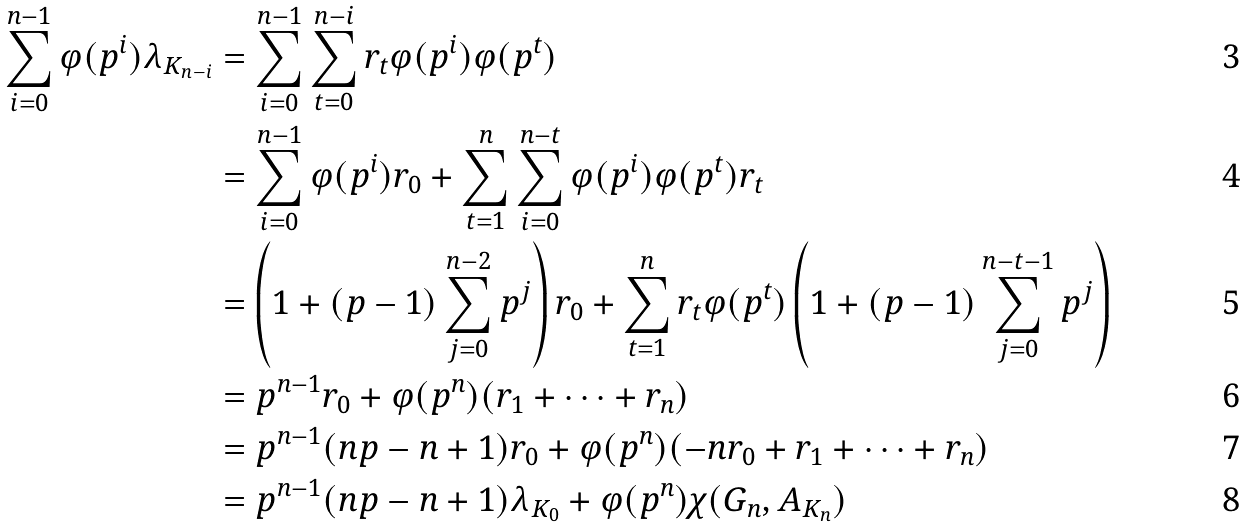Convert formula to latex. <formula><loc_0><loc_0><loc_500><loc_500>\sum _ { i = 0 } ^ { n - 1 } \varphi ( p ^ { i } ) \lambda _ { K _ { n - i } } & = \sum _ { i = 0 } ^ { n - 1 } \sum _ { t = 0 } ^ { n - i } r _ { t } \varphi ( p ^ { i } ) \varphi ( p ^ { t } ) \\ & = \sum _ { i = 0 } ^ { n - 1 } \varphi ( p ^ { i } ) r _ { 0 } + \sum _ { t = 1 } ^ { n } \sum _ { i = 0 } ^ { n - t } \varphi ( p ^ { i } ) \varphi ( p ^ { t } ) r _ { t } \\ & = \left ( 1 + ( p - 1 ) \sum _ { j = 0 } ^ { n - 2 } p ^ { j } \right ) r _ { 0 } + \sum _ { t = 1 } ^ { n } r _ { t } \varphi ( p ^ { t } ) \left ( 1 + ( p - 1 ) \sum _ { j = 0 } ^ { n - t - 1 } p ^ { j } \right ) \\ & = p ^ { n - 1 } r _ { 0 } + \varphi ( p ^ { n } ) ( r _ { 1 } + \cdots + r _ { n } ) \\ & = p ^ { n - 1 } ( n p - n + 1 ) r _ { 0 } + \varphi ( p ^ { n } ) ( - n r _ { 0 } + r _ { 1 } + \cdots + r _ { n } ) \\ & = p ^ { n - 1 } ( n p - n + 1 ) \lambda _ { K _ { 0 } } + \varphi ( p ^ { n } ) \chi ( G _ { n } , A _ { K _ { n } } )</formula> 